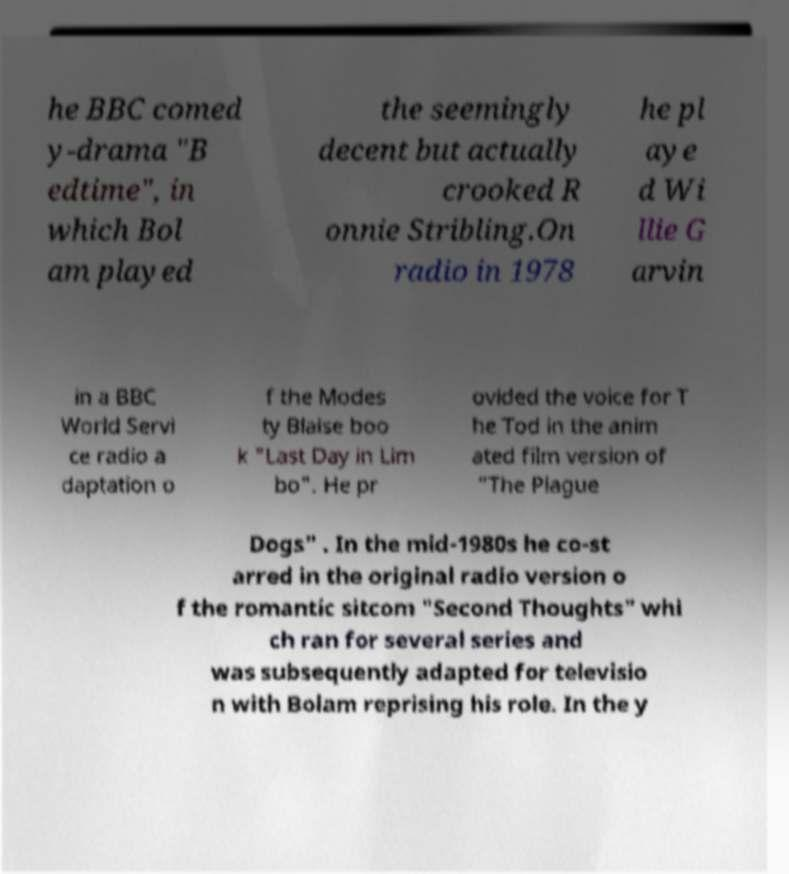Please read and relay the text visible in this image. What does it say? he BBC comed y-drama "B edtime", in which Bol am played the seemingly decent but actually crooked R onnie Stribling.On radio in 1978 he pl aye d Wi llie G arvin in a BBC World Servi ce radio a daptation o f the Modes ty Blaise boo k "Last Day in Lim bo". He pr ovided the voice for T he Tod in the anim ated film version of "The Plague Dogs" . In the mid-1980s he co-st arred in the original radio version o f the romantic sitcom "Second Thoughts" whi ch ran for several series and was subsequently adapted for televisio n with Bolam reprising his role. In the y 